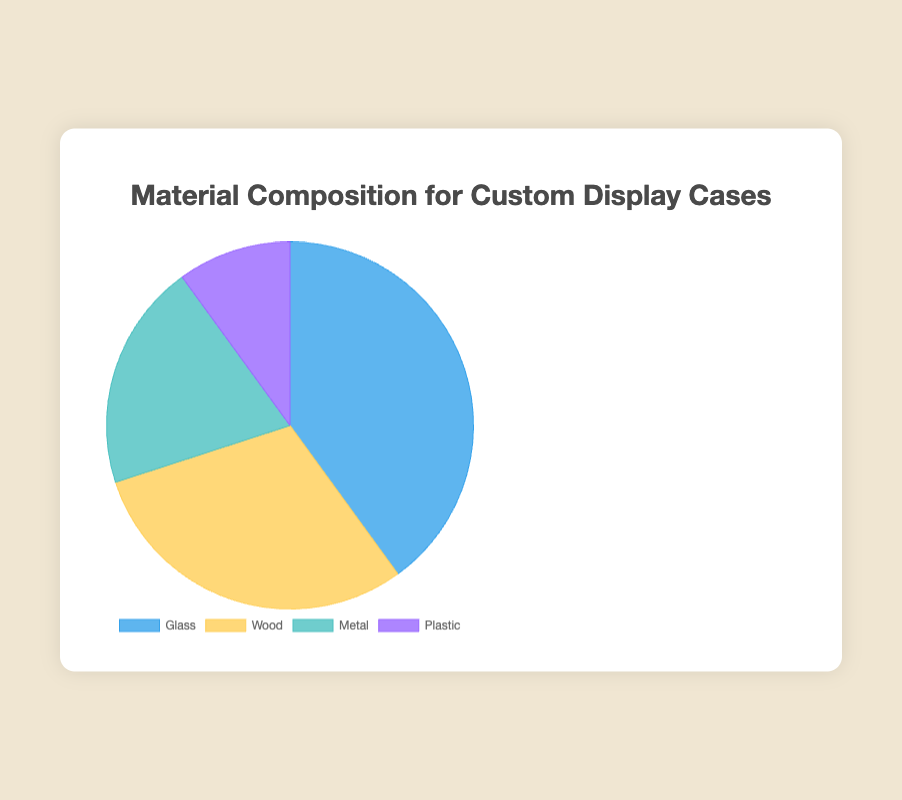What material constitutes the largest percentage in the custom display cases? By examining the pie chart, you can see that the segment for 'Glass' is the largest, occupying 40% of the composition.
Answer: Glass What is the combined percentage of Wood and Metal in the custom display cases? From the pie chart, the percentage for Wood is 30% and Metal is 20%. Adding these gives 30% + 20% = 50%.
Answer: 50% Which material has the smallest contribution to the custom display cases? Looking at the pie chart, the smallest segment represents 'Plastic', which contributes 10%.
Answer: Plastic How much larger is the percentage of Glass compared to Plastic? The pie chart shows that Glass is 40% and Plastic is 10%. The difference is 40% - 10% = 30%.
Answer: 30% What is the average percentage composition for all materials in the custom display cases? The percentages are 40% (Glass), 30% (Wood), 20% (Metal), and 10% (Plastic). To find the average: (40 + 30 + 20 + 10) / 4 = 100 / 4 = 25%.
Answer: 25% If the percentage of Metal were to double, what would its new percentage be? Metal's current percentage is 20%. Doubling it gives 20% * 2 = 40%.
Answer: 40% Which two materials have a combined percentage that is equal to the percentage of Glass? The pie chart shows Glass at 40%. Combining Wood (30%) and Plastic (10%) gives 30% + 10% = 40%, which matches the percentage of Glass.
Answer: Wood and Plastic Rank the materials from highest to lowest composition percentage. From the pie chart, the percentages are: Glass (40%), Wood (30%), Metal (20%), and Plastic (10%).
Answer: Glass, Wood, Metal, Plastic Is the percentage of Metal greater than that of Plastic? By examining the pie chart, Metal is 20% and Plastic is 10%. Since 20% is greater than 10%, Metal's percentage is indeed greater.
Answer: Yes How much would the total percentage be if the percentage of Wood is reduced by 5%? Wood's current percentage is 30%. Reducing it by 5% gives 30% - 5% = 25%. Summing the new values: 40% (Glass) + 25% (Wood) + 20% (Metal) + 10% (Plastic) = 95%.
Answer: 95% 